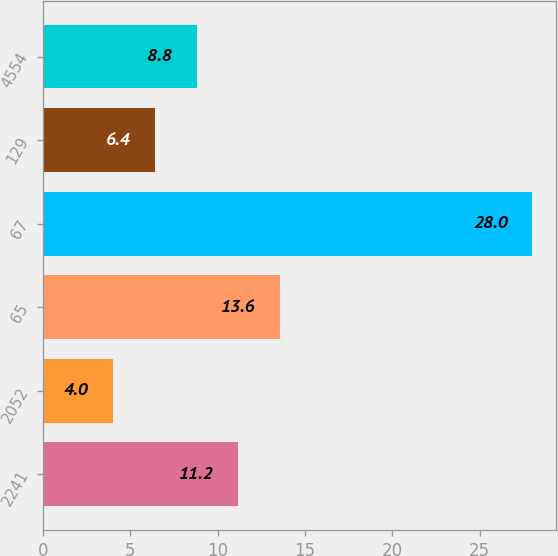<chart> <loc_0><loc_0><loc_500><loc_500><bar_chart><fcel>2241<fcel>2052<fcel>65<fcel>67<fcel>129<fcel>4554<nl><fcel>11.2<fcel>4<fcel>13.6<fcel>28<fcel>6.4<fcel>8.8<nl></chart> 